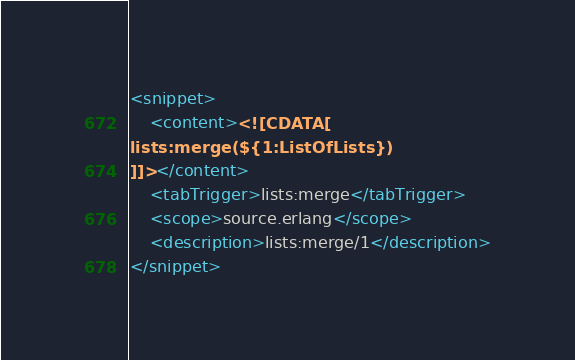Convert code to text. <code><loc_0><loc_0><loc_500><loc_500><_XML_><snippet>
    <content><![CDATA[
lists:merge(${1:ListOfLists})
]]></content>
    <tabTrigger>lists:merge</tabTrigger>
    <scope>source.erlang</scope>
    <description>lists:merge/1</description>
</snippet></code> 